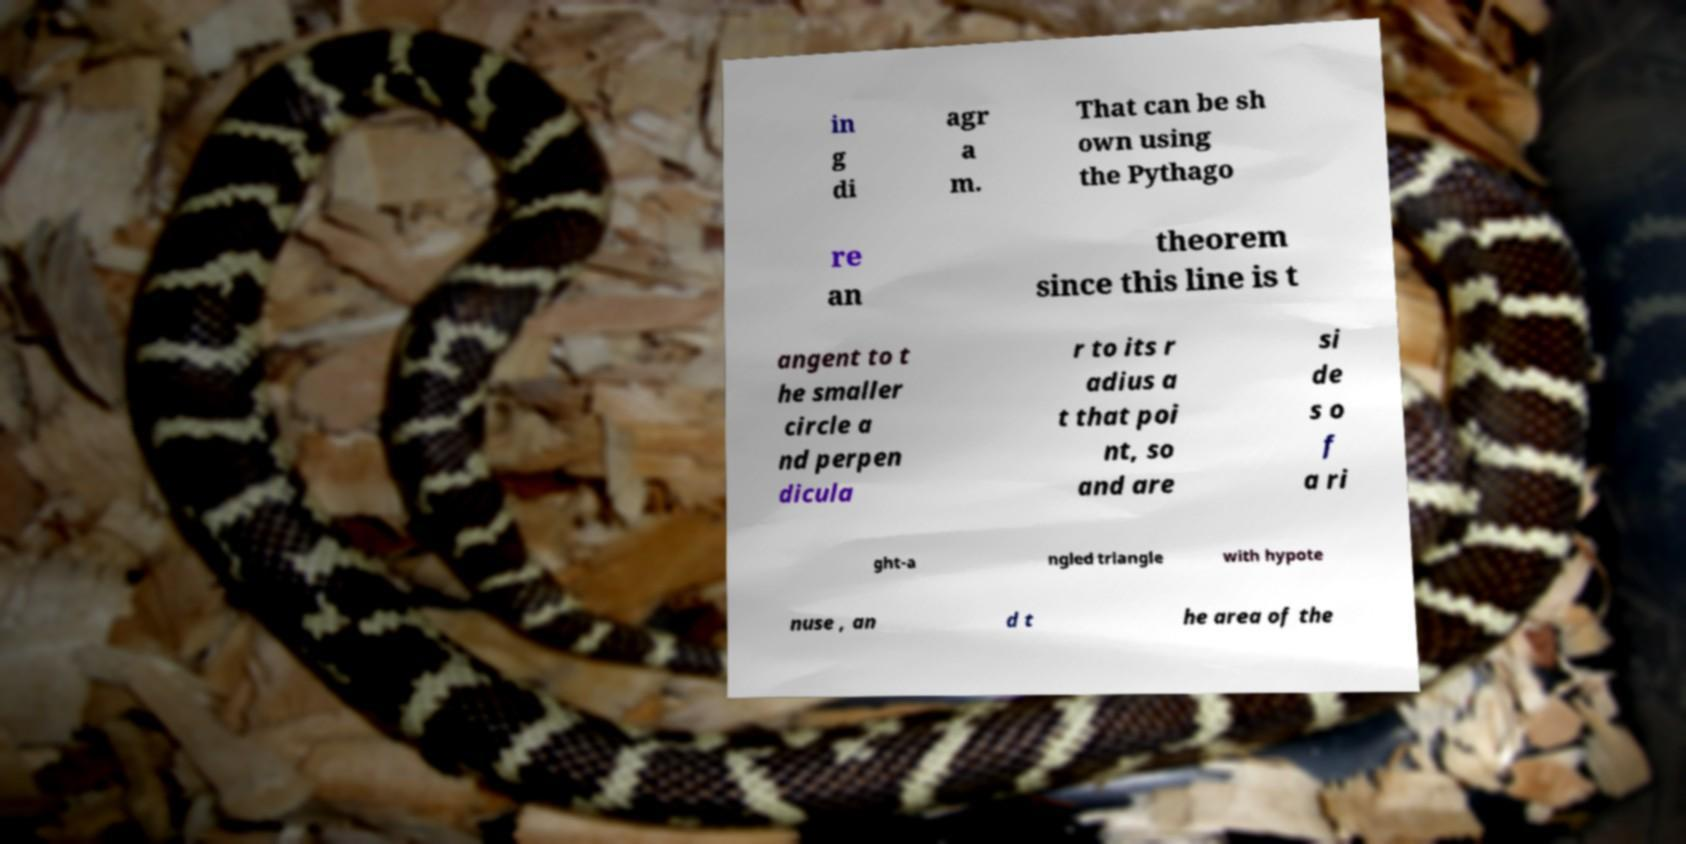Could you assist in decoding the text presented in this image and type it out clearly? in g di agr a m. That can be sh own using the Pythago re an theorem since this line is t angent to t he smaller circle a nd perpen dicula r to its r adius a t that poi nt, so and are si de s o f a ri ght-a ngled triangle with hypote nuse , an d t he area of the 